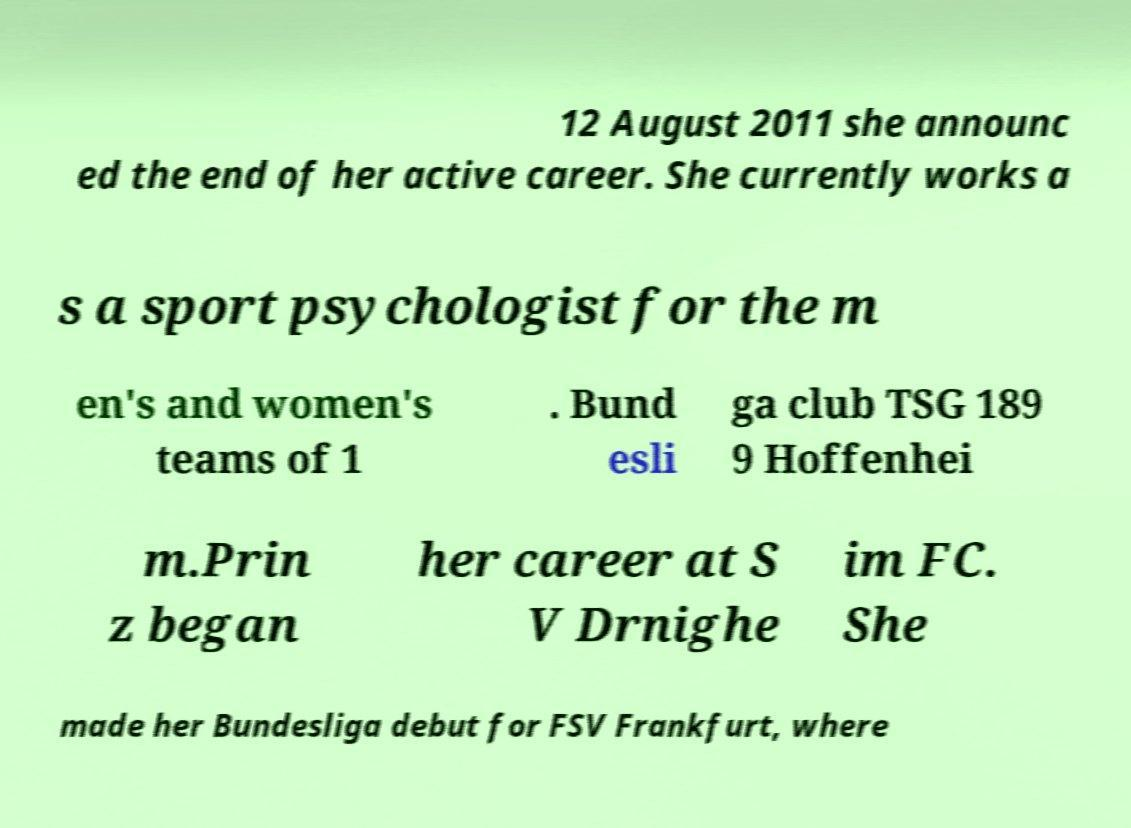Could you extract and type out the text from this image? 12 August 2011 she announc ed the end of her active career. She currently works a s a sport psychologist for the m en's and women's teams of 1 . Bund esli ga club TSG 189 9 Hoffenhei m.Prin z began her career at S V Drnighe im FC. She made her Bundesliga debut for FSV Frankfurt, where 